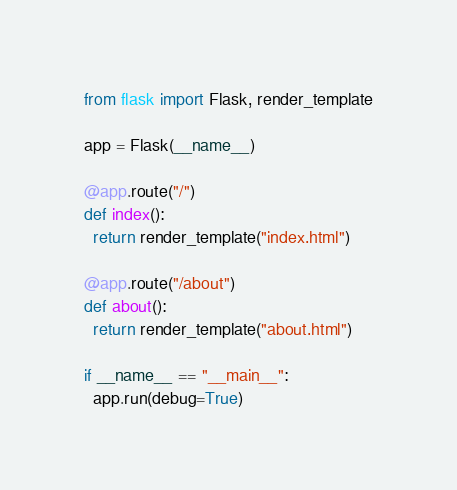<code> <loc_0><loc_0><loc_500><loc_500><_Python_>from flask import Flask, render_template

app = Flask(__name__)

@app.route("/")
def index():
  return render_template("index.html")

@app.route("/about")
def about():
  return render_template("about.html")

if __name__ == "__main__":
  app.run(debug=True)
</code> 